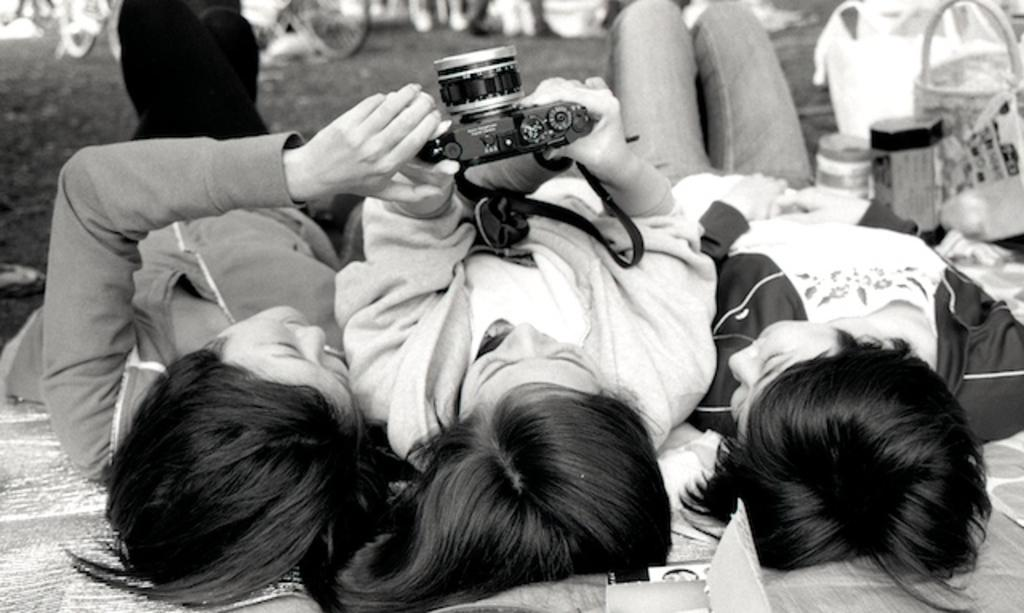What are the three persons in the image doing? The three persons in the image are lying down. What are the two persons holding in the image? The two persons are holding a camera. What can be seen in the image besides the persons and the camera? There is a basket visible in the image. What is present on the floor in the image? There are objects on the floor in the image. What type of pickle is being held by the owner in the image? There is no pickle or owner present in the image. 